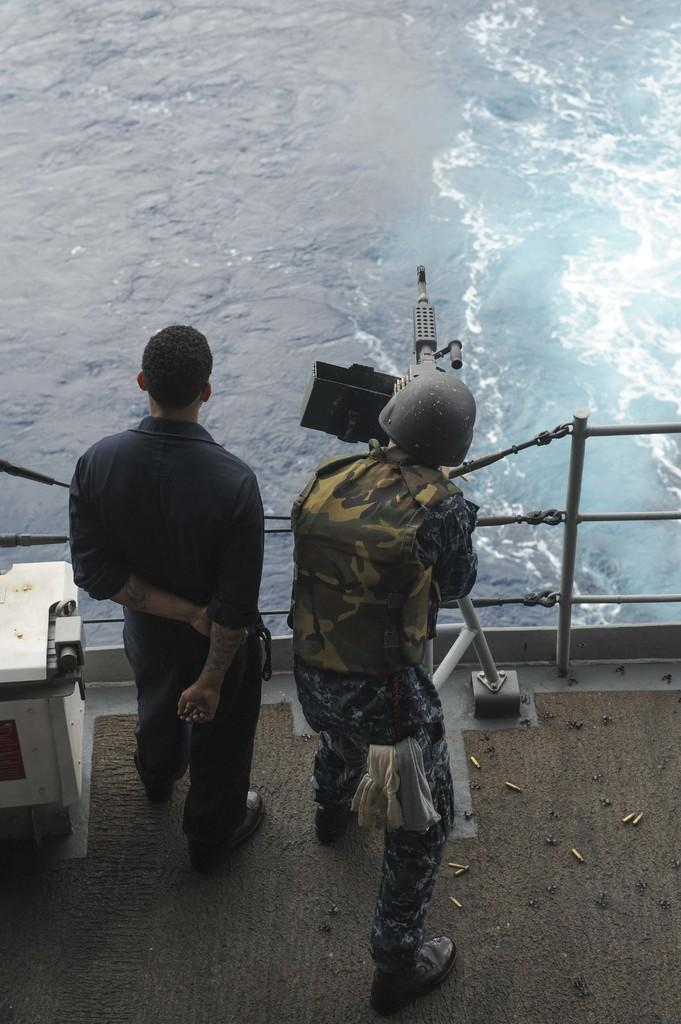What is present in the image that is not a person or a machine gun? There is water visible in the image. What is the person on the right side of the image holding? The person on the right side of the image is holding a machine gun. Can you describe the position of the person on the left side of the image? There is a person standing on the left side of the image. What type of knot is the person on the left side of the image tying in the image? There is no knot present in the image, nor is there any indication that the person on the left side of the image is tying a knot. 